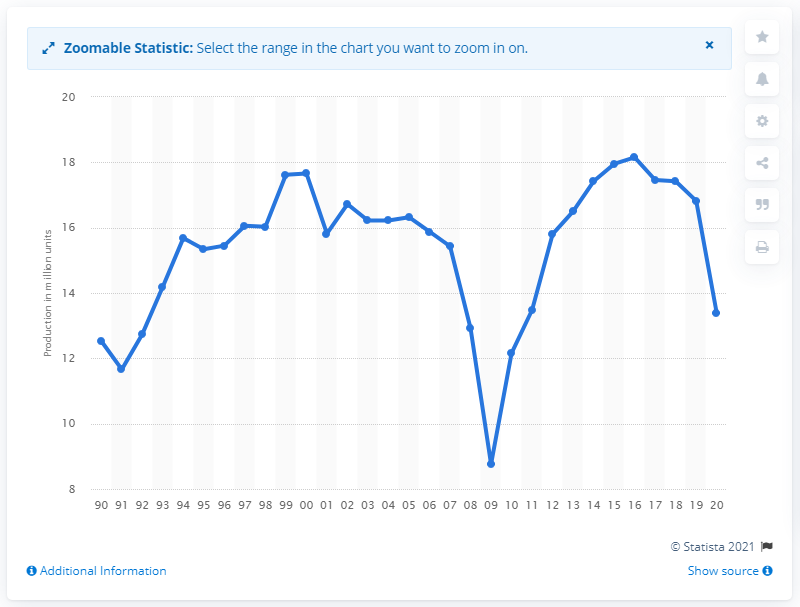Highlight a few significant elements in this photo. In 2020, a total of 13,380,000 motor vehicles were produced in North America. 